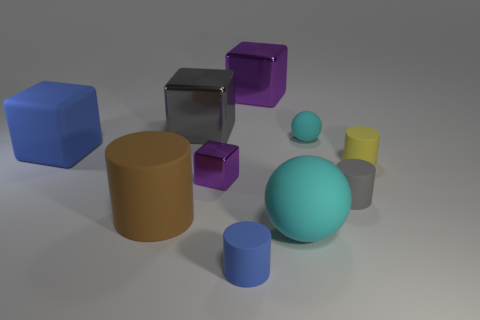Subtract all cylinders. How many objects are left? 6 Add 8 cyan things. How many cyan things are left? 10 Add 9 big purple matte spheres. How many big purple matte spheres exist? 9 Subtract 1 yellow cylinders. How many objects are left? 9 Subtract all brown rubber cylinders. Subtract all tiny metal cubes. How many objects are left? 8 